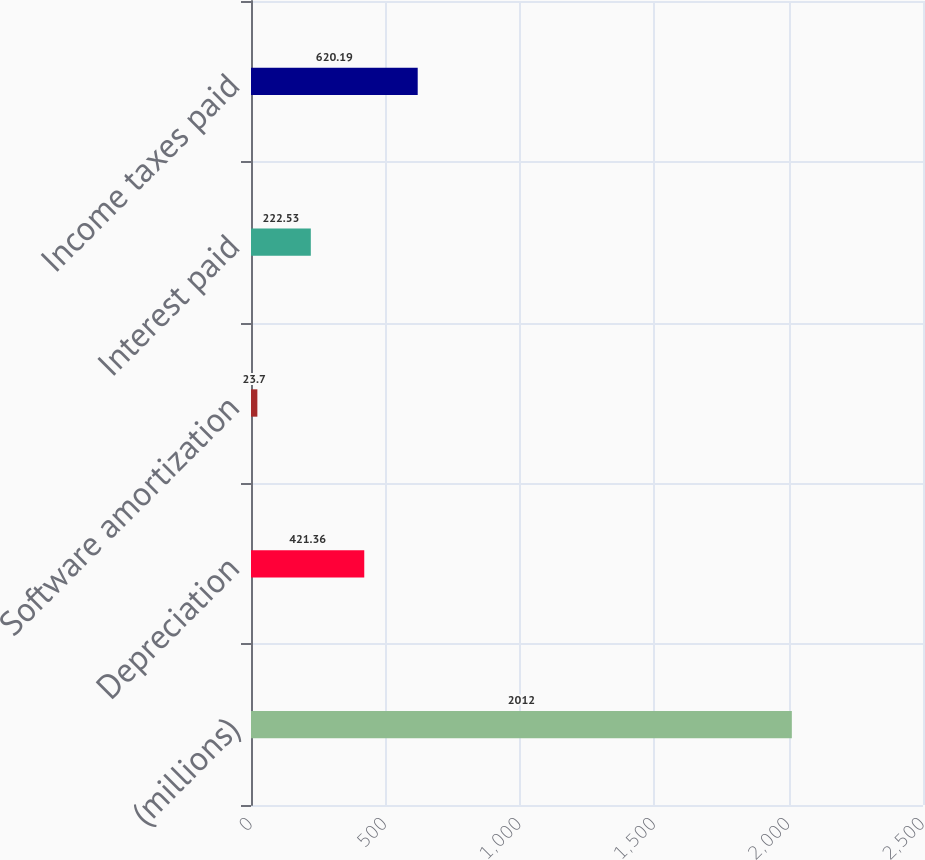Convert chart to OTSL. <chart><loc_0><loc_0><loc_500><loc_500><bar_chart><fcel>(millions)<fcel>Depreciation<fcel>Software amortization<fcel>Interest paid<fcel>Income taxes paid<nl><fcel>2012<fcel>421.36<fcel>23.7<fcel>222.53<fcel>620.19<nl></chart> 